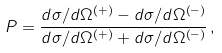<formula> <loc_0><loc_0><loc_500><loc_500>P = \frac { d \sigma / d \Omega ^ { \left ( + \right ) } - d \sigma / d \Omega ^ { \left ( - \right ) } } { d \sigma / d \Omega ^ { \left ( + \right ) } + d \sigma / d \Omega ^ { \left ( - \right ) } } \, ,</formula> 